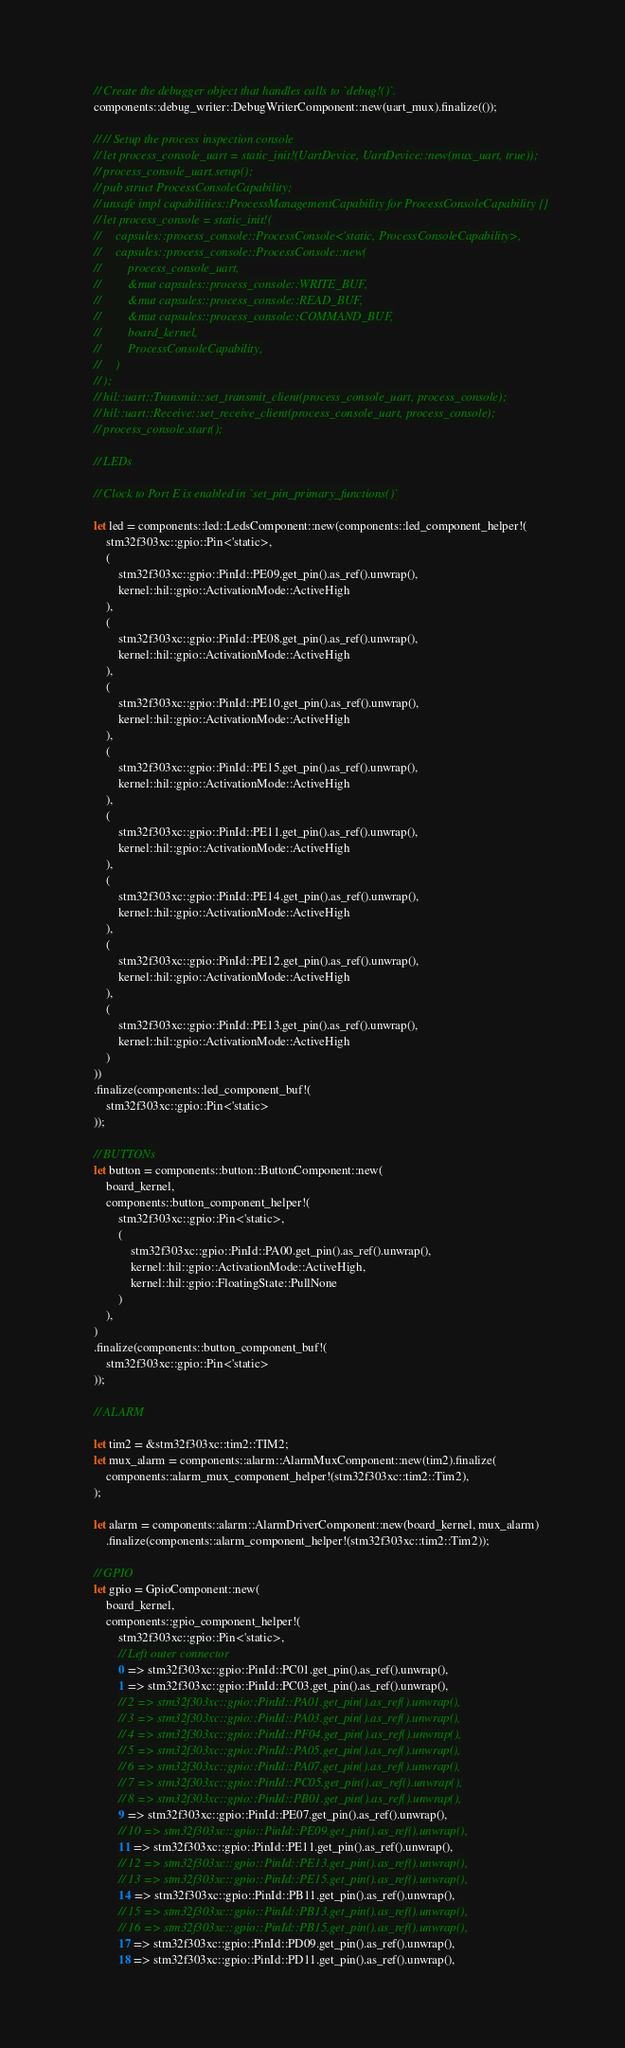<code> <loc_0><loc_0><loc_500><loc_500><_Rust_>    // Create the debugger object that handles calls to `debug!()`.
    components::debug_writer::DebugWriterComponent::new(uart_mux).finalize(());

    // // Setup the process inspection console
    // let process_console_uart = static_init!(UartDevice, UartDevice::new(mux_uart, true));
    // process_console_uart.setup();
    // pub struct ProcessConsoleCapability;
    // unsafe impl capabilities::ProcessManagementCapability for ProcessConsoleCapability {}
    // let process_console = static_init!(
    //     capsules::process_console::ProcessConsole<'static, ProcessConsoleCapability>,
    //     capsules::process_console::ProcessConsole::new(
    //         process_console_uart,
    //         &mut capsules::process_console::WRITE_BUF,
    //         &mut capsules::process_console::READ_BUF,
    //         &mut capsules::process_console::COMMAND_BUF,
    //         board_kernel,
    //         ProcessConsoleCapability,
    //     )
    // );
    // hil::uart::Transmit::set_transmit_client(process_console_uart, process_console);
    // hil::uart::Receive::set_receive_client(process_console_uart, process_console);
    // process_console.start();

    // LEDs

    // Clock to Port E is enabled in `set_pin_primary_functions()`

    let led = components::led::LedsComponent::new(components::led_component_helper!(
        stm32f303xc::gpio::Pin<'static>,
        (
            stm32f303xc::gpio::PinId::PE09.get_pin().as_ref().unwrap(),
            kernel::hil::gpio::ActivationMode::ActiveHigh
        ),
        (
            stm32f303xc::gpio::PinId::PE08.get_pin().as_ref().unwrap(),
            kernel::hil::gpio::ActivationMode::ActiveHigh
        ),
        (
            stm32f303xc::gpio::PinId::PE10.get_pin().as_ref().unwrap(),
            kernel::hil::gpio::ActivationMode::ActiveHigh
        ),
        (
            stm32f303xc::gpio::PinId::PE15.get_pin().as_ref().unwrap(),
            kernel::hil::gpio::ActivationMode::ActiveHigh
        ),
        (
            stm32f303xc::gpio::PinId::PE11.get_pin().as_ref().unwrap(),
            kernel::hil::gpio::ActivationMode::ActiveHigh
        ),
        (
            stm32f303xc::gpio::PinId::PE14.get_pin().as_ref().unwrap(),
            kernel::hil::gpio::ActivationMode::ActiveHigh
        ),
        (
            stm32f303xc::gpio::PinId::PE12.get_pin().as_ref().unwrap(),
            kernel::hil::gpio::ActivationMode::ActiveHigh
        ),
        (
            stm32f303xc::gpio::PinId::PE13.get_pin().as_ref().unwrap(),
            kernel::hil::gpio::ActivationMode::ActiveHigh
        )
    ))
    .finalize(components::led_component_buf!(
        stm32f303xc::gpio::Pin<'static>
    ));

    // BUTTONs
    let button = components::button::ButtonComponent::new(
        board_kernel,
        components::button_component_helper!(
            stm32f303xc::gpio::Pin<'static>,
            (
                stm32f303xc::gpio::PinId::PA00.get_pin().as_ref().unwrap(),
                kernel::hil::gpio::ActivationMode::ActiveHigh,
                kernel::hil::gpio::FloatingState::PullNone
            )
        ),
    )
    .finalize(components::button_component_buf!(
        stm32f303xc::gpio::Pin<'static>
    ));

    // ALARM

    let tim2 = &stm32f303xc::tim2::TIM2;
    let mux_alarm = components::alarm::AlarmMuxComponent::new(tim2).finalize(
        components::alarm_mux_component_helper!(stm32f303xc::tim2::Tim2),
    );

    let alarm = components::alarm::AlarmDriverComponent::new(board_kernel, mux_alarm)
        .finalize(components::alarm_component_helper!(stm32f303xc::tim2::Tim2));

    // GPIO
    let gpio = GpioComponent::new(
        board_kernel,
        components::gpio_component_helper!(
            stm32f303xc::gpio::Pin<'static>,
            // Left outer connector
            0 => stm32f303xc::gpio::PinId::PC01.get_pin().as_ref().unwrap(),
            1 => stm32f303xc::gpio::PinId::PC03.get_pin().as_ref().unwrap(),
            // 2 => stm32f303xc::gpio::PinId::PA01.get_pin().as_ref().unwrap(),
            // 3 => stm32f303xc::gpio::PinId::PA03.get_pin().as_ref().unwrap(),
            // 4 => stm32f303xc::gpio::PinId::PF04.get_pin().as_ref().unwrap(),
            // 5 => stm32f303xc::gpio::PinId::PA05.get_pin().as_ref().unwrap(),
            // 6 => stm32f303xc::gpio::PinId::PA07.get_pin().as_ref().unwrap(),
            // 7 => stm32f303xc::gpio::PinId::PC05.get_pin().as_ref().unwrap(),
            // 8 => stm32f303xc::gpio::PinId::PB01.get_pin().as_ref().unwrap(),
            9 => stm32f303xc::gpio::PinId::PE07.get_pin().as_ref().unwrap(),
            // 10 => stm32f303xc::gpio::PinId::PE09.get_pin().as_ref().unwrap(),
            11 => stm32f303xc::gpio::PinId::PE11.get_pin().as_ref().unwrap(),
            // 12 => stm32f303xc::gpio::PinId::PE13.get_pin().as_ref().unwrap(),
            // 13 => stm32f303xc::gpio::PinId::PE15.get_pin().as_ref().unwrap(),
            14 => stm32f303xc::gpio::PinId::PB11.get_pin().as_ref().unwrap(),
            // 15 => stm32f303xc::gpio::PinId::PB13.get_pin().as_ref().unwrap(),
            // 16 => stm32f303xc::gpio::PinId::PB15.get_pin().as_ref().unwrap(),
            17 => stm32f303xc::gpio::PinId::PD09.get_pin().as_ref().unwrap(),
            18 => stm32f303xc::gpio::PinId::PD11.get_pin().as_ref().unwrap(),</code> 